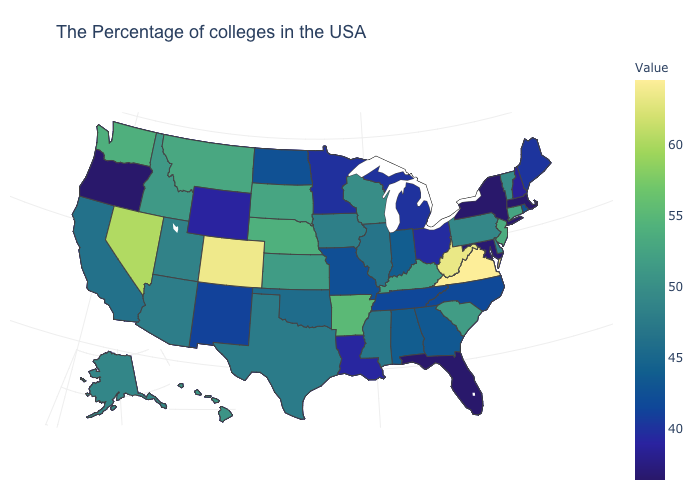Among the states that border Arkansas , does Louisiana have the lowest value?
Quick response, please. Yes. Does Virginia have the highest value in the USA?
Answer briefly. Yes. Which states hav the highest value in the MidWest?
Short answer required. Nebraska. Among the states that border New York , which have the highest value?
Quick response, please. New Jersey. Among the states that border Oklahoma , which have the highest value?
Give a very brief answer. Colorado. Among the states that border Delaware , does Maryland have the lowest value?
Short answer required. Yes. 